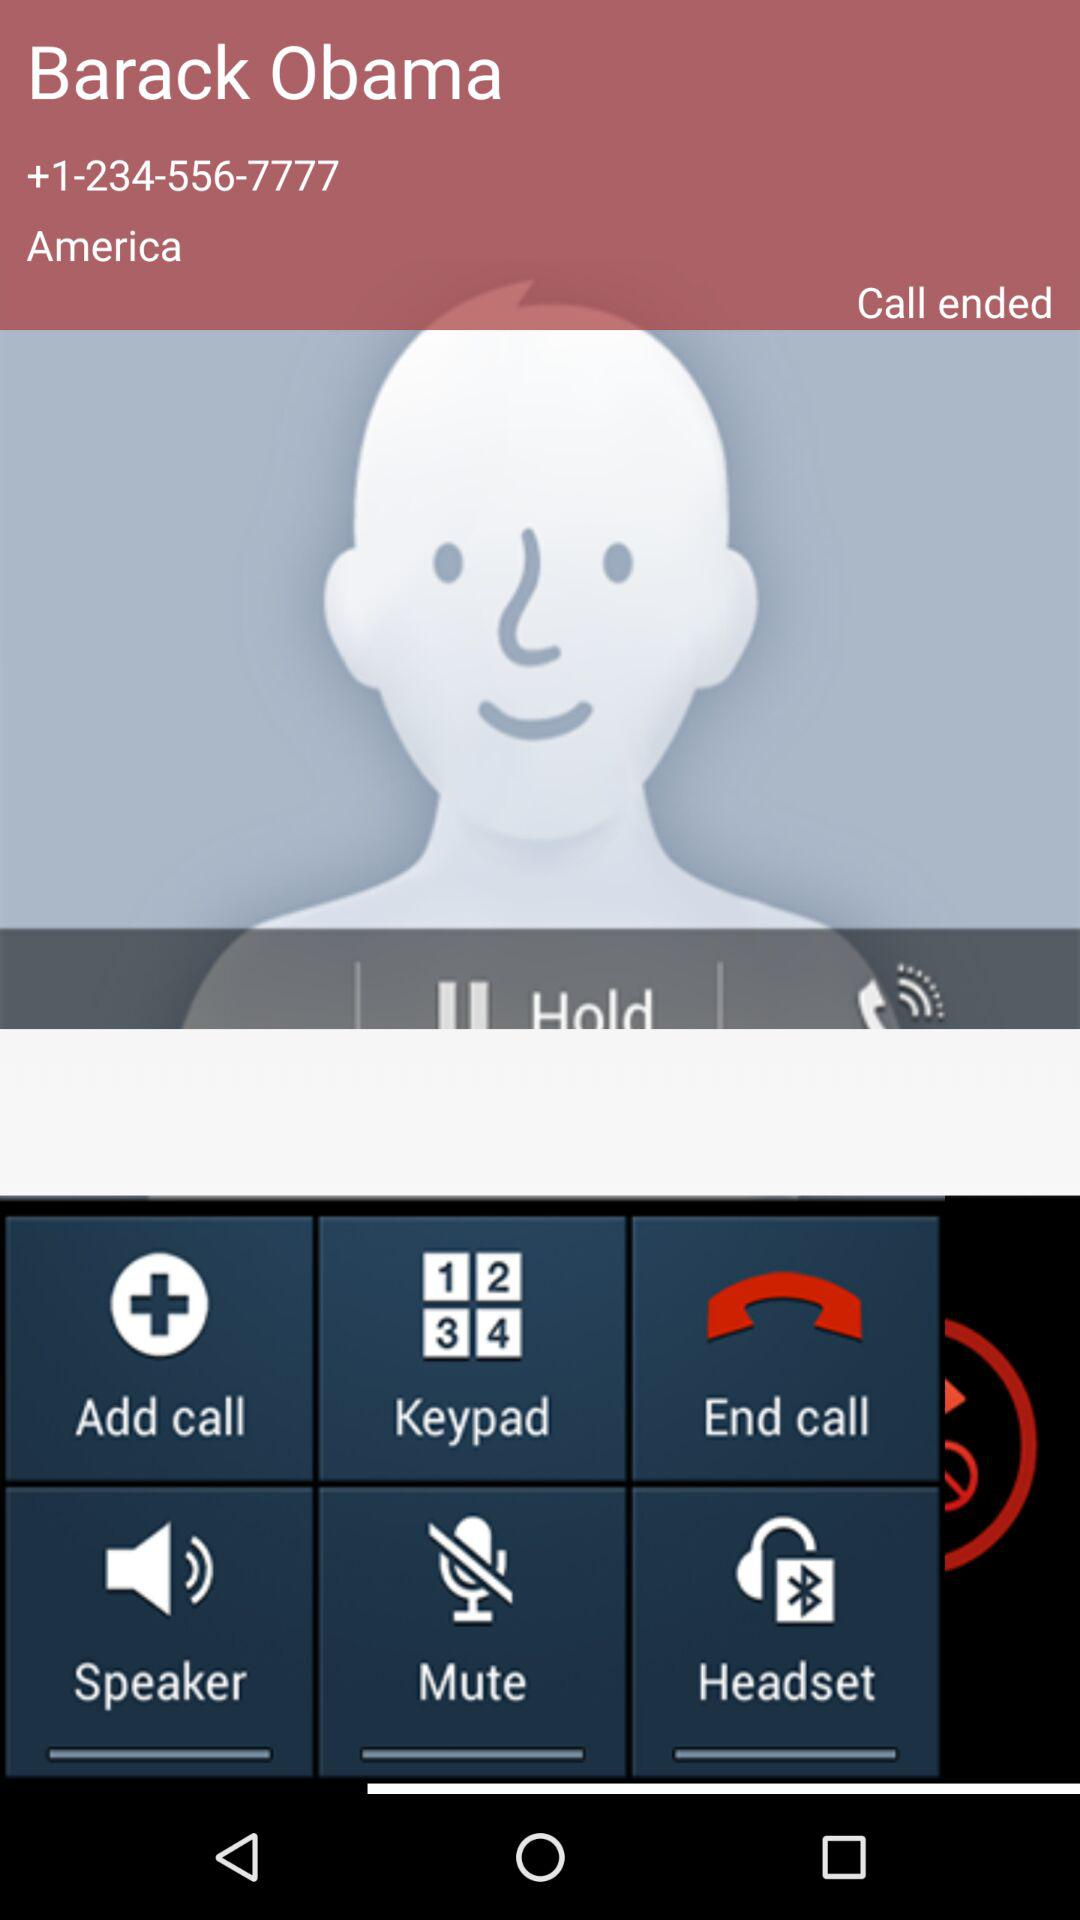What is the phone number available on the screen? The phone number is +1-234-556-7777. 